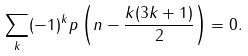Convert formula to latex. <formula><loc_0><loc_0><loc_500><loc_500>\sum _ { k } ( - 1 ) ^ { k } p \left ( n - \frac { k ( 3 k + 1 ) } { 2 } \right ) = 0 .</formula> 